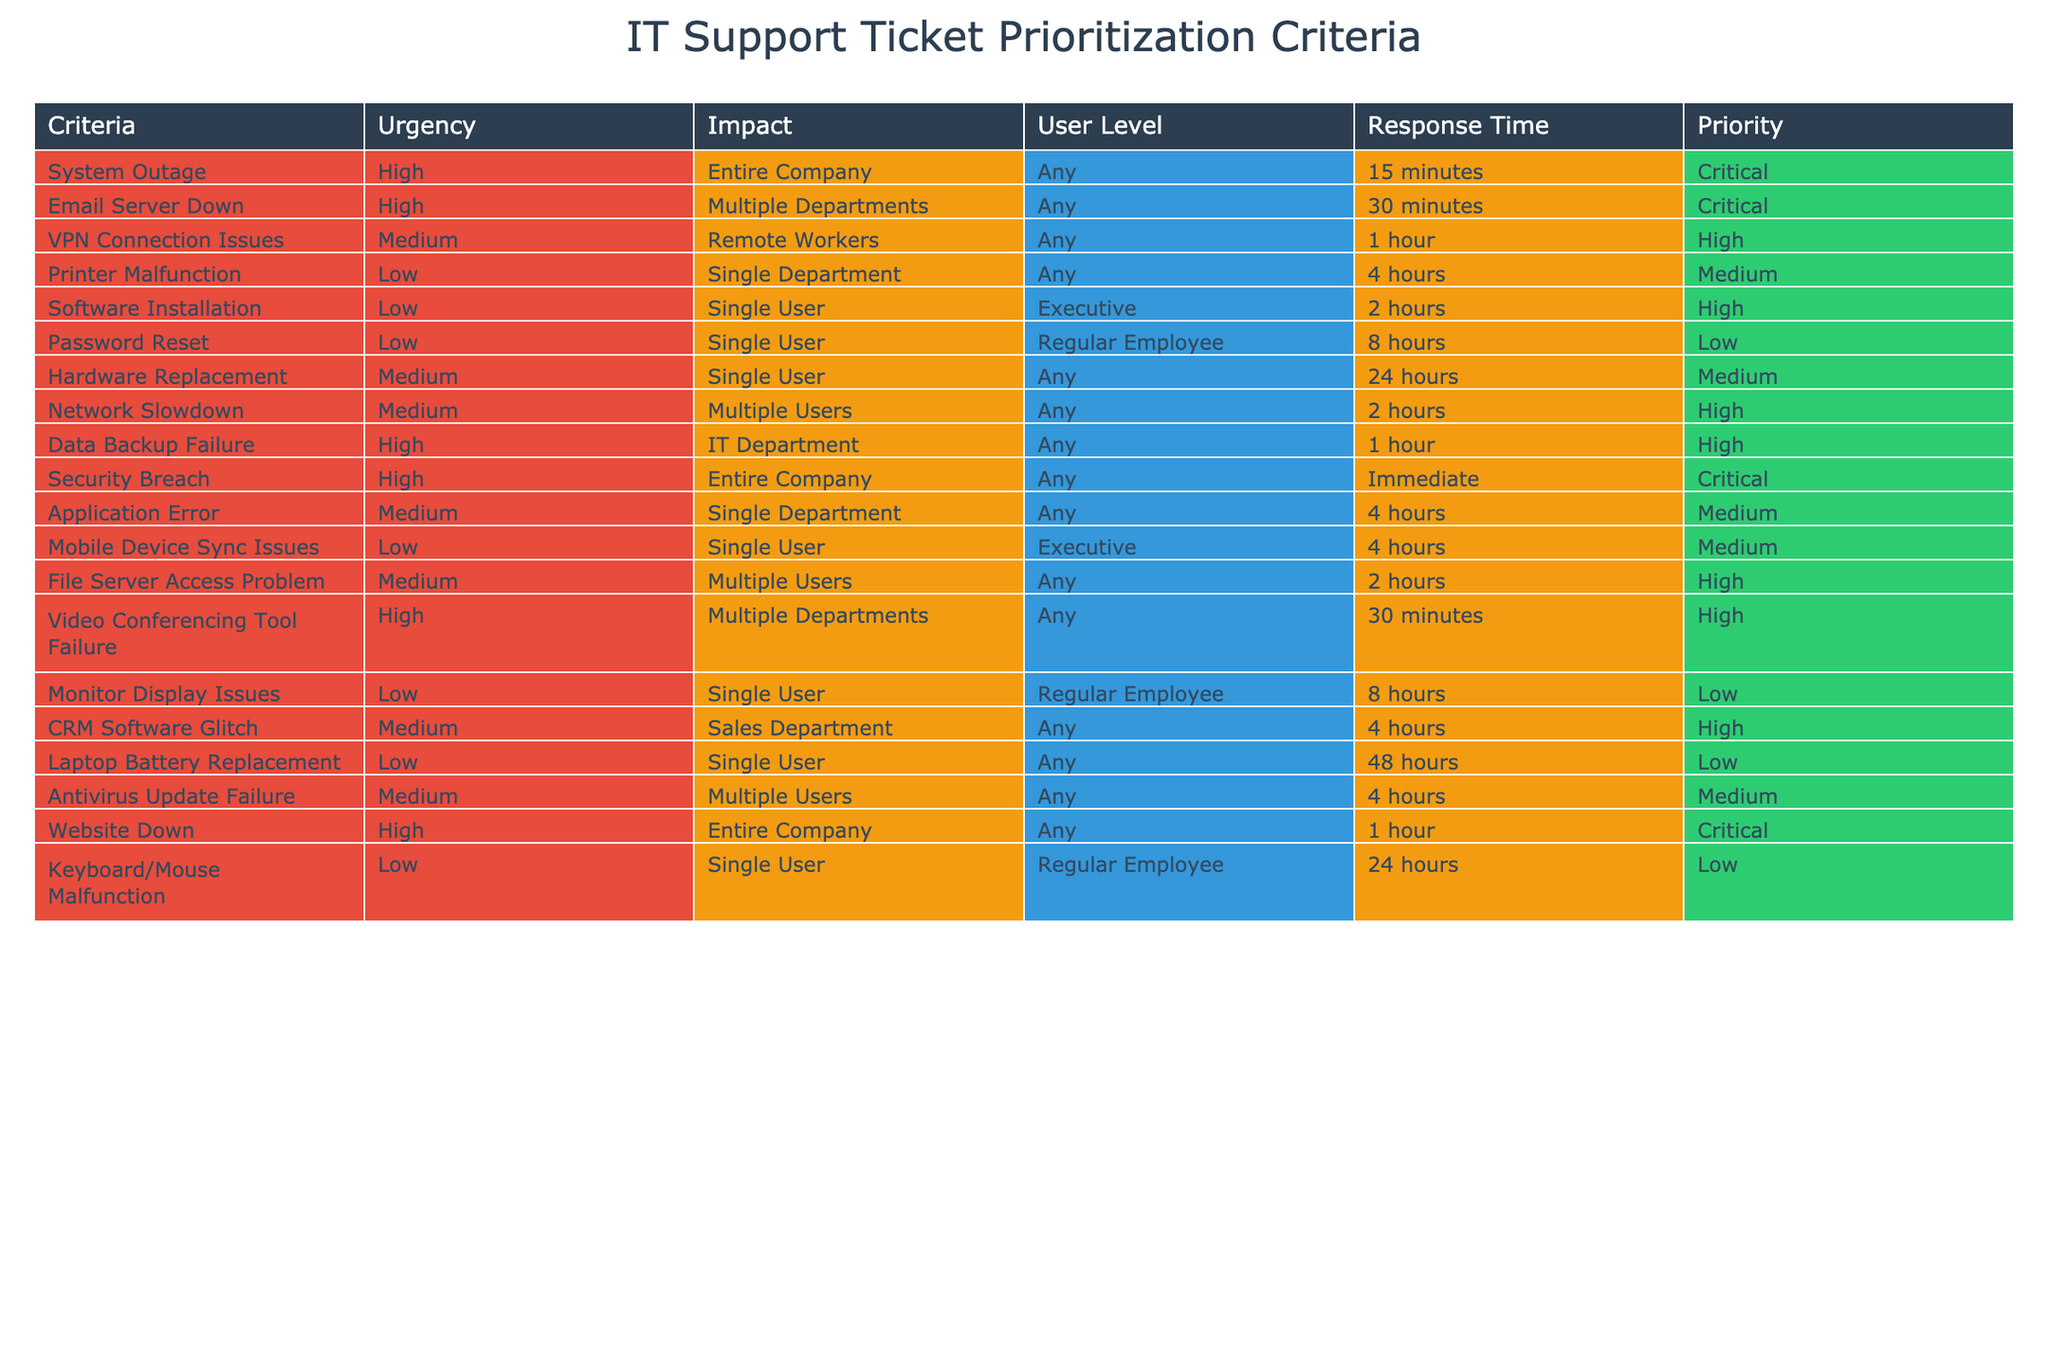What is the response time for 'VPN Connection Issues'? The table lists the response time for each type of IT support ticket. By looking at the row for 'VPN Connection Issues', it shows that the response time is 1 hour.
Answer: 1 hour How many total tickets have 'High' priority? To find this, we count the number of instances marked as 'High' in the Priority column. The table shows 6 tickets with High priority.
Answer: 6 Is 'Password Reset' ticket categorized as 'Critical'? By examining the row for 'Password Reset', it is noted that the priority is listed as 'Low', which means it is not categorized as 'Critical'.
Answer: No What is the average response time for all 'Medium' priority tickets? First, we identify all tickets with 'Medium' priority in the table. There are 4 such tickets with response times of 4 hours, 24 hours, 4 hours, and 4 hours. Then we convert these hours into total minutes: (4 * 60) + (24 * 60) + (4 * 60) + (4 * 60) = 240 + 1440 + 240 + 240 = 2160 minutes. Divided by 4 gives an average of 2160/4 = 540 minutes, which converts back to 9 hours.
Answer: 9 hours What is the highest urgency level among all the tickets? Looking through the Urgency column in the table, we see that 'High' and 'Critical' are the highest urgency levels. The highest urgency level is therefore 'Critical'.
Answer: Critical 